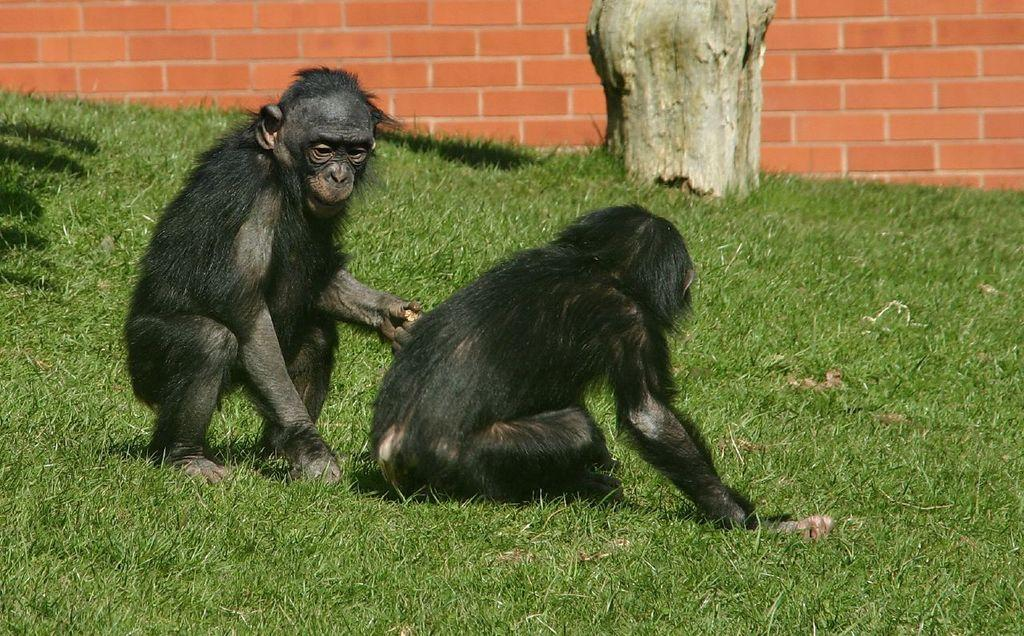How many monkeys are present in the image? There are two monkeys in the image. What type of vegetation can be seen in the image? There is grass visible in the image. What can be seen in the background of the image? There is a wall in the background of the image. Is there a river flowing through the grass in the image? No, there is no river present in the image. 